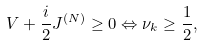Convert formula to latex. <formula><loc_0><loc_0><loc_500><loc_500>V + \frac { i } { 2 } J ^ { ( N ) } \geq 0 \Leftrightarrow \nu _ { k } \geq \frac { 1 } { 2 } ,</formula> 